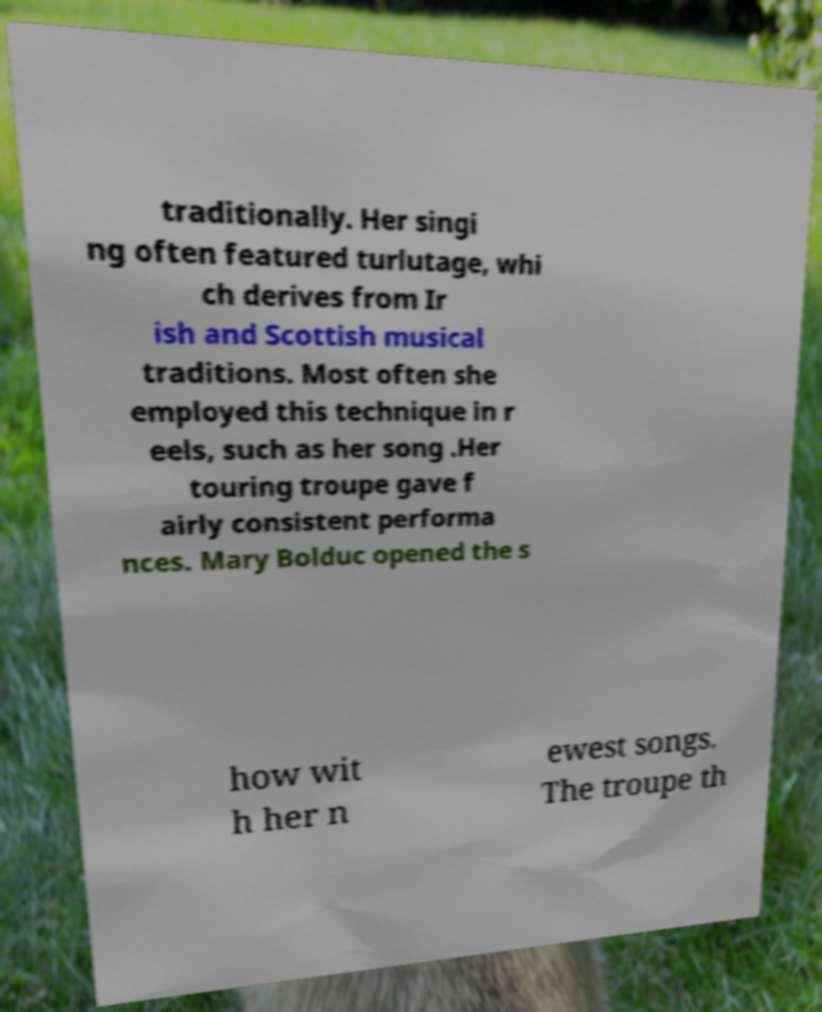Please read and relay the text visible in this image. What does it say? traditionally. Her singi ng often featured turlutage, whi ch derives from Ir ish and Scottish musical traditions. Most often she employed this technique in r eels, such as her song .Her touring troupe gave f airly consistent performa nces. Mary Bolduc opened the s how wit h her n ewest songs. The troupe th 